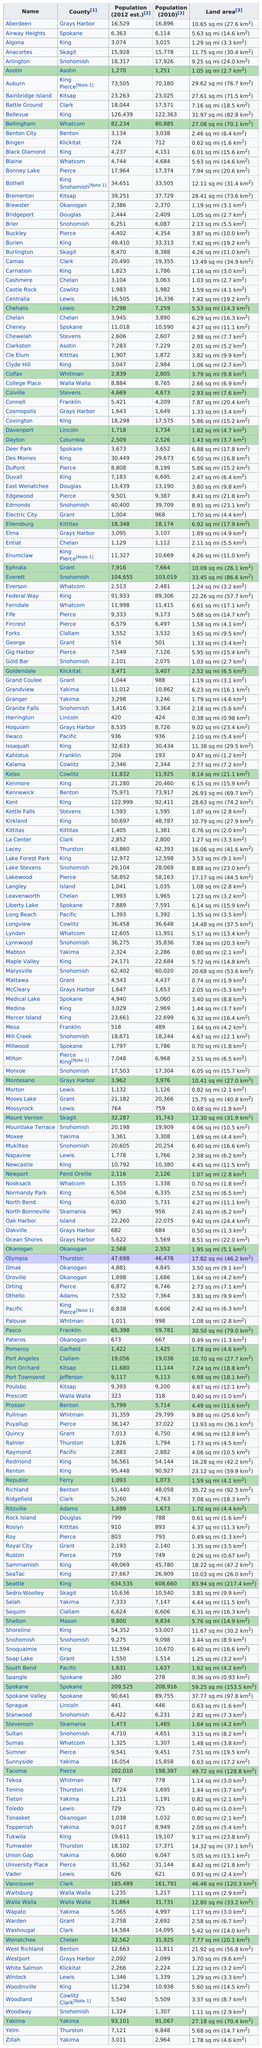Specify some key components in this picture. Seattle is the town with the largest square miles if you want to live in an area with a large amount of land. 